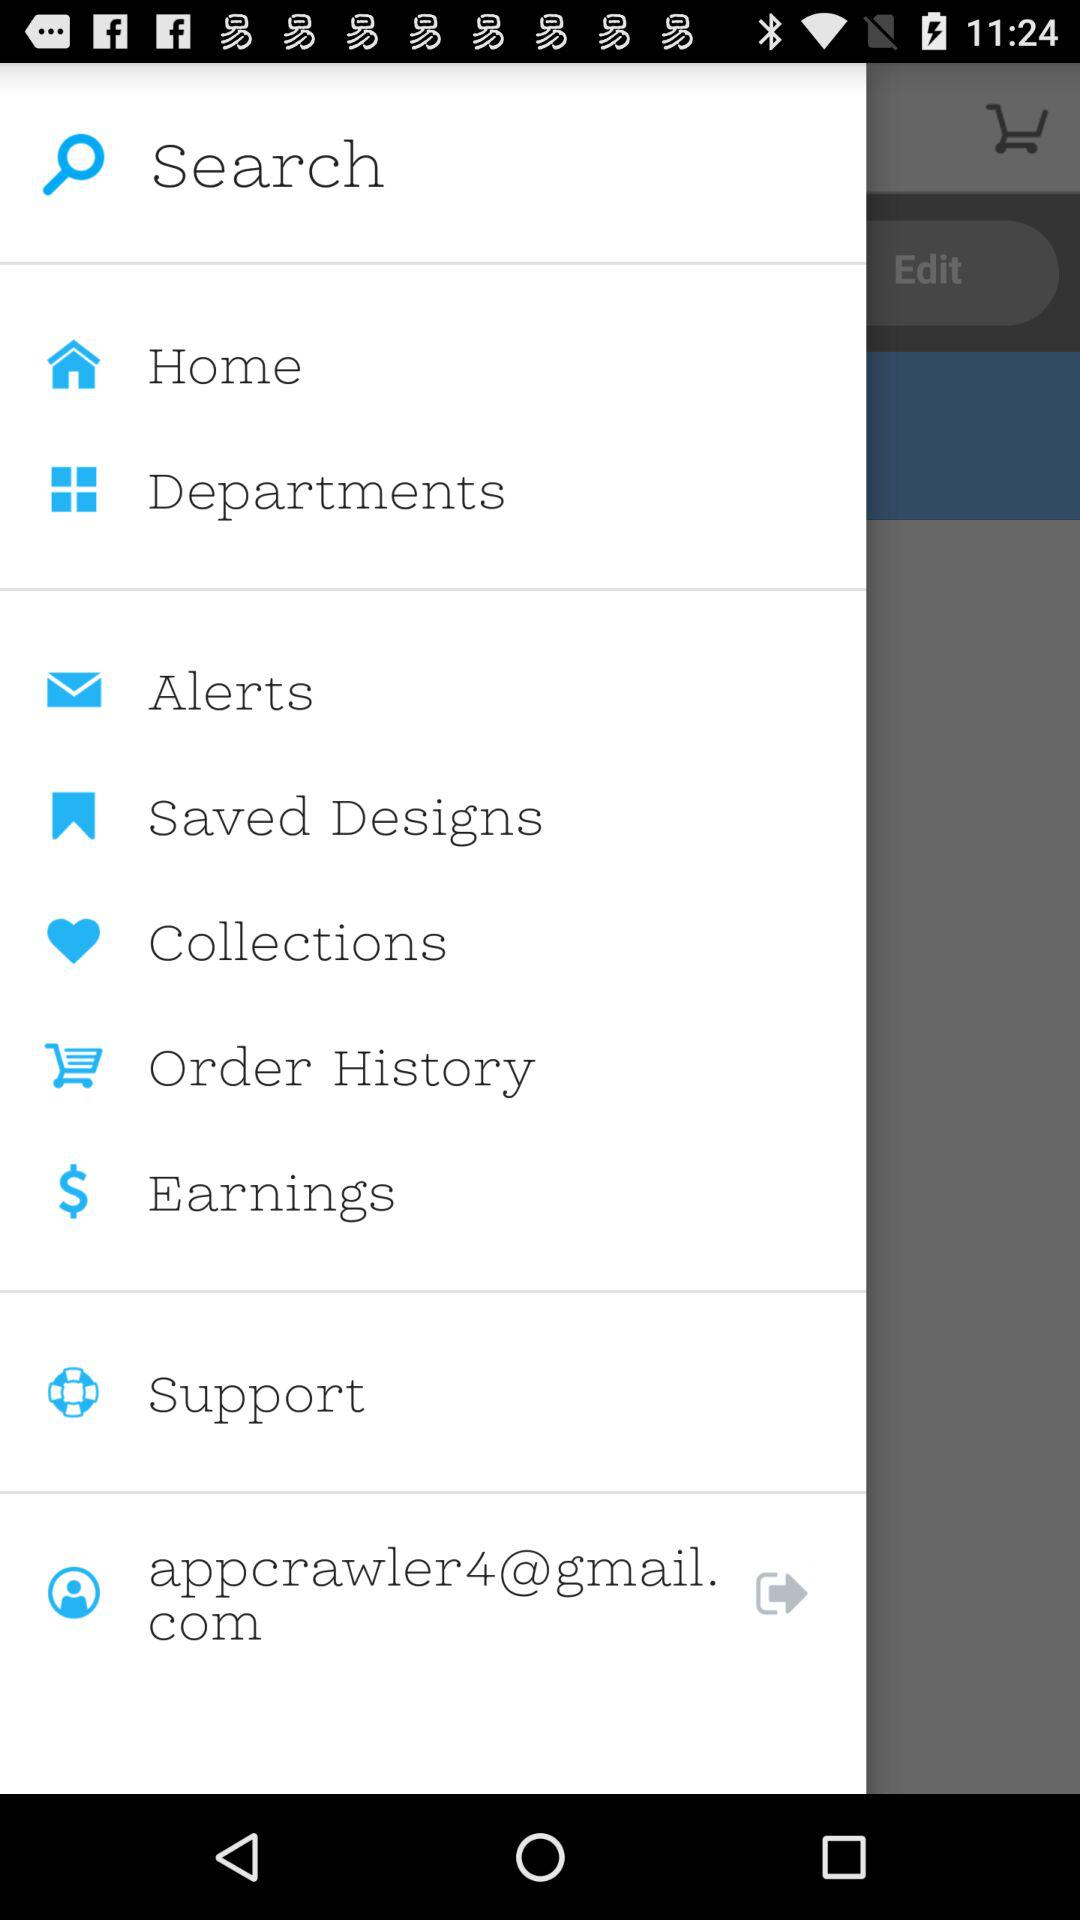What is the Gmail address? The Gmail address is appcrawler4@gmail.com. 